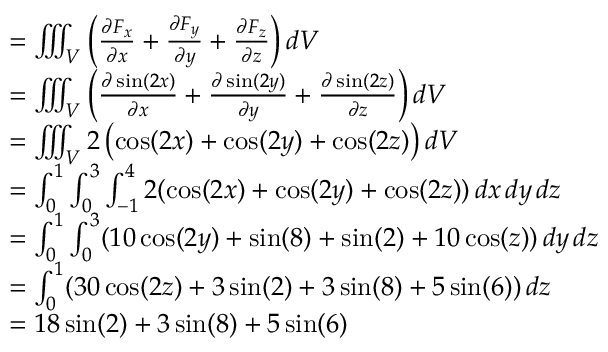Convert formula to latex. <formula><loc_0><loc_0><loc_500><loc_500>{ \begin{array} { r l } & { = \iiint _ { V } \left ( { \frac { \partial F _ { x } } { \partial x } } + { \frac { \partial F _ { y } } { \partial y } } + { \frac { \partial F _ { z } } { \partial z } } \right ) d V } \\ & { = \iiint _ { V } \left ( { \frac { \partial \sin ( 2 x ) } { \partial x } } + { \frac { \partial \sin ( 2 y ) } { \partial y } } + { \frac { \partial \sin ( 2 z ) } { \partial z } } \right ) d V } \\ & { = \iiint _ { V } 2 \left ( \cos ( 2 x ) + \cos ( 2 y ) + \cos ( 2 z ) \right ) d V } \\ & { = \int _ { 0 } ^ { 1 } \int _ { 0 } ^ { 3 } \int _ { - 1 } ^ { 4 } 2 ( \cos ( 2 x ) + \cos ( 2 y ) + \cos ( 2 z ) ) \, d x \, d y \, d z } \\ & { = \int _ { 0 } ^ { 1 } \int _ { 0 } ^ { 3 } ( 1 0 \cos ( 2 y ) + \sin ( 8 ) + \sin ( 2 ) + 1 0 \cos ( z ) ) \, d y \, d z } \\ & { = \int _ { 0 } ^ { 1 } ( 3 0 \cos ( 2 z ) + 3 \sin ( 2 ) + 3 \sin ( 8 ) + 5 \sin ( 6 ) ) \, d z } \\ & { = 1 8 \sin ( 2 ) + 3 \sin ( 8 ) + 5 \sin ( 6 ) } \end{array} }</formula> 